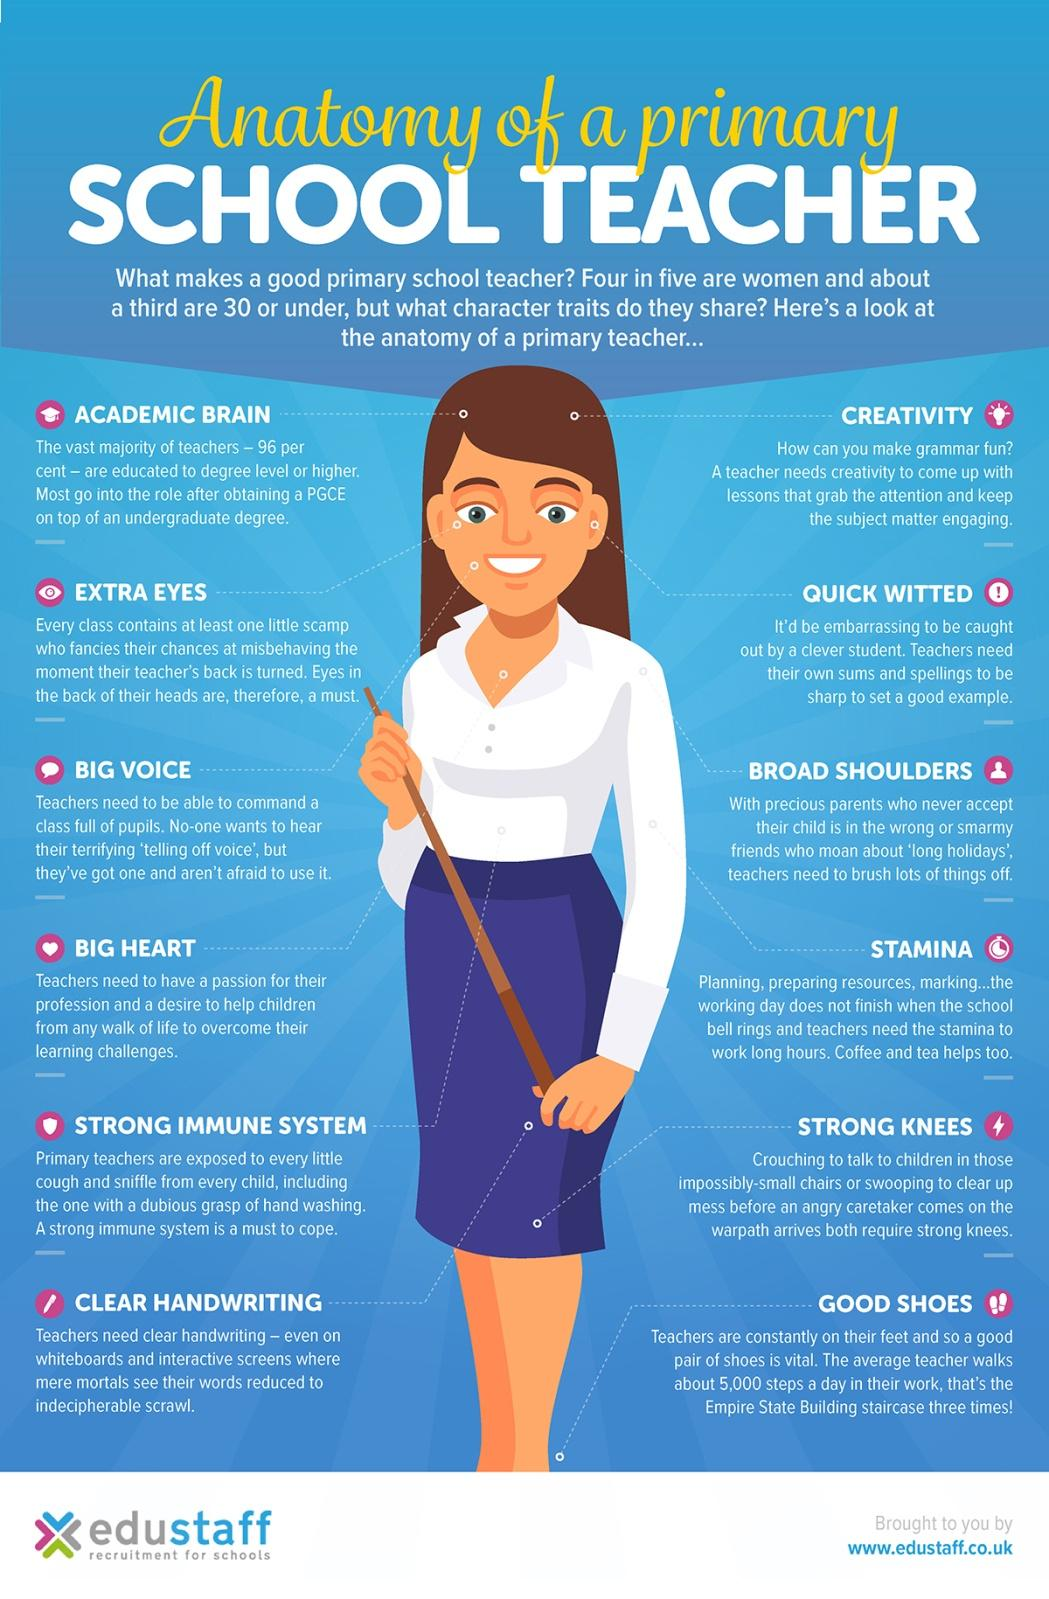Highlight a few significant elements in this photo. Coffee and tea are beverages that provide extra stamina to primary school teachers. 